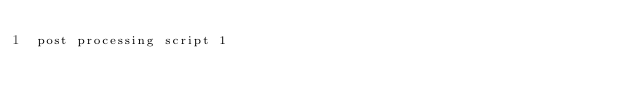<code> <loc_0><loc_0><loc_500><loc_500><_SQL_>post processing script 1</code> 